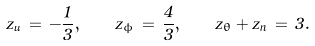<formula> <loc_0><loc_0><loc_500><loc_500>z _ { u } \, = \, - \frac { 1 } { 3 } , \quad z _ { \phi } \, = \, \frac { 4 } { 3 } , \quad z _ { \theta } + z _ { n } \, = \, 3 .</formula> 